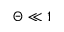<formula> <loc_0><loc_0><loc_500><loc_500>\Theta \ll 1</formula> 